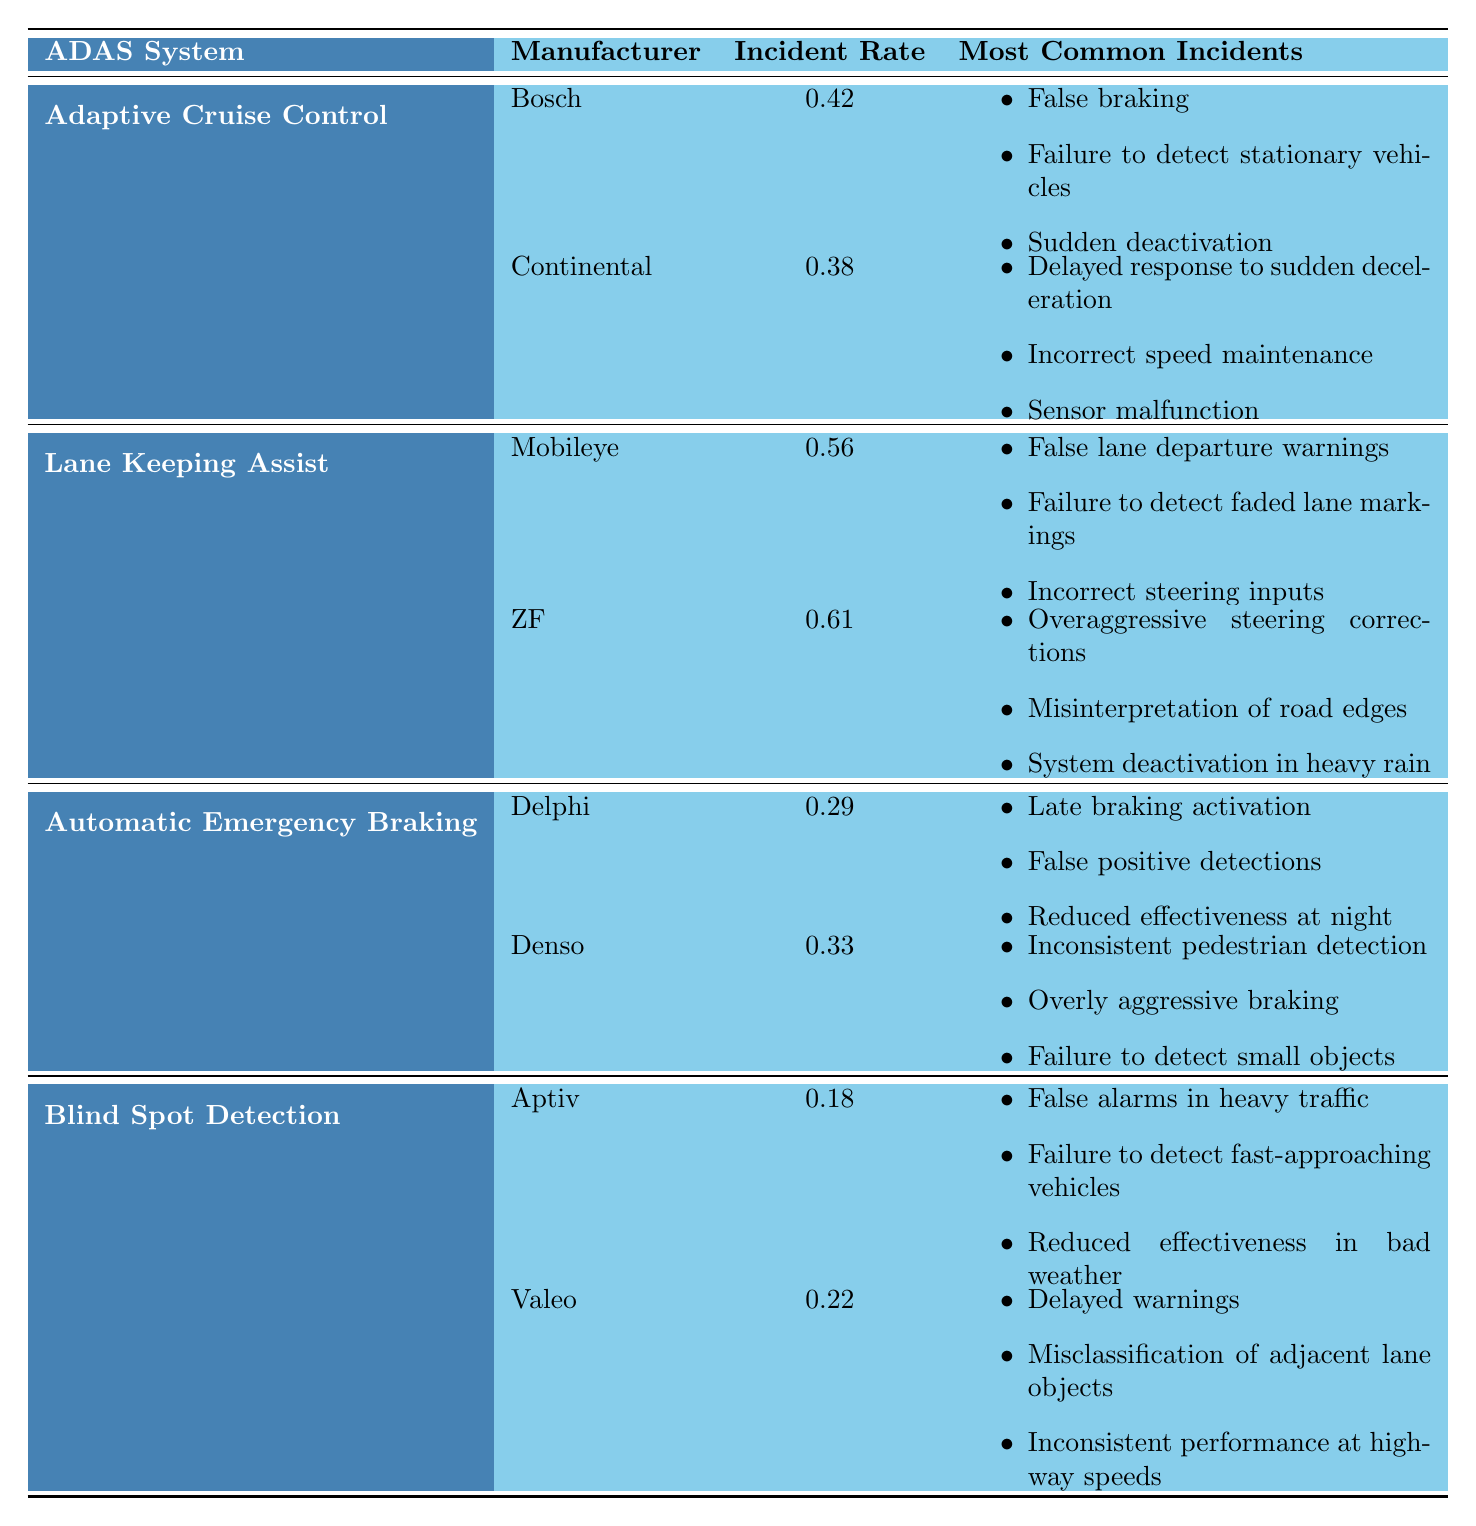What's the incident rate of Bosch's Adaptive Cruise Control? According to the table, Bosch has an incident rate of 0.42 incidents per 100,000 miles for Adaptive Cruise Control.
Answer: 0.42 Which ADAS system has the lowest incident rate? The table shows that Blind Spot Detection, manufactured by Aptiv, has the lowest incident rate at 0.18 incidents per 100,000 miles.
Answer: Blind Spot Detection What is the average incident rate for the Lane Keeping Assist systems? We have two manufacturers: Mobileye (0.56) and ZF (0.61). Summing these gives 0.56 + 0.61 = 1.17. The average is 1.17 / 2 = 0.585.
Answer: 0.585 True or False: Denso has a higher incident rate than Delphi for Automatic Emergency Braking. Denso has an incident rate of 0.33, while Delphi has 0.29. Since 0.33 is greater than 0.29, the statement is true.
Answer: True What are the most common incidents for Valeo's Blind Spot Detection? The table lists Valeo's most common incidents, which include: delayed warnings, misclassification of adjacent lane objects, and inconsistent performance at highway speeds.
Answer: Delayed warnings, misclassification of adjacent lane objects, inconsistent performance at highway speeds Which system has the highest incident rate when considering only manufacturers with rates above 0.4? The relevant manufacturers are Bosch (0.42), Mobileye (0.56), ZF (0.61), and Continental (0.38 does not qualify). Among these, ZF has the highest incident rate at 0.61.
Answer: Lane Keeping Assist Calculate the difference in incident rates between the highest and lowest ADAS systems. Lane Keeping Assist has the highest incident rate of 0.61 (ZF), whereas Blind Spot Detection has the lowest at 0.18 (Aptiv). The difference is 0.61 - 0.18 = 0.43.
Answer: 0.43 Does Automatic Emergency Braking have a higher incidence of late braking activation than Adaptive Cruise Control's false braking incidents? Automatic Emergency Braking reports late braking activation as a common incident, while Adaptive Cruise Control reports false braking. However, we cannot compare rates without specific values for these incidents; this becomes a qualitative comparison. Thus, the determination cannot be made strictly from the table.
Answer: No definitive answer (qualitative comparison) What are the most common incidents for the Lane Keeping Assist system? The given table lists the most common incidents for the Lane Keeping Assist systems (Mobileye and ZF), which are: false lane departure warnings, failure to detect faded lane markings, incorrect steering inputs for Mobileye and overaggressive steering corrections, misinterpretation of road edges, and system deactivation in heavy rain for ZF.
Answer: False lane departure warnings, failure to detect faded lane markings, incorrect steering inputs; also includes overaggressive steering corrections, misinterpretation of road edges, system deactivation in heavy rain 